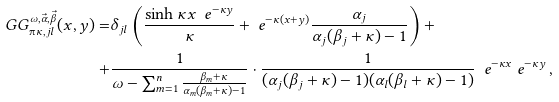<formula> <loc_0><loc_0><loc_500><loc_500>\ G G ^ { \omega , \vec { \alpha } , \vec { \beta } } _ { \i \kappa , j l } ( x , y ) = & \delta _ { j l } \left ( \frac { \sinh \kappa x \ \ e ^ { - \kappa y } } { \kappa } + \ e ^ { - \kappa ( x + y ) } \frac { \alpha _ { j } } { \alpha _ { j } ( \beta _ { j } + \kappa ) - 1 } \right ) + \\ + & \frac { 1 } { \omega - \sum ^ { n } _ { m = 1 } \frac { \beta _ { m } + \kappa } { \alpha _ { m } ( \beta _ { m } + \kappa ) - 1 } } \cdot \frac { 1 } { ( \alpha _ { j } ( \beta _ { j } + \kappa ) - 1 ) ( \alpha _ { l } ( \beta _ { l } + \kappa ) - 1 ) } \ \ e ^ { - \kappa x } \ e ^ { - \kappa y } \, ,</formula> 